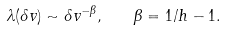Convert formula to latex. <formula><loc_0><loc_0><loc_500><loc_500>\lambda ( \delta v ) \sim \delta v ^ { - \beta } , \quad \beta = 1 / h - 1 .</formula> 